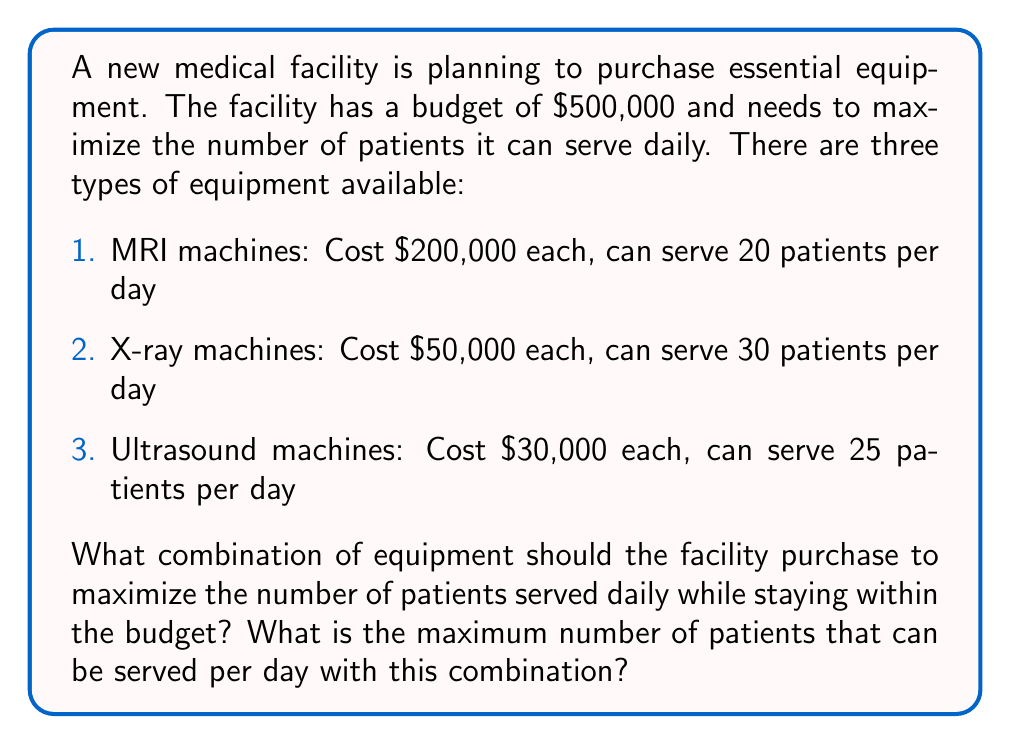Can you answer this question? To solve this optimization problem, we'll use the linear programming method. Let's define our variables:

$x$ = number of MRI machines
$y$ = number of X-ray machines
$z$ = number of Ultrasound machines

Our objective function is to maximize the number of patients served daily:

$$ \text{Maximize: } 20x + 30y + 25z $$

Subject to the constraints:

1. Budget constraint: $200,000x + 50,000y + 30,000z \leq 500,000$
2. Non-negativity: $x, y, z \geq 0$
3. Integer constraint: $x, y, z$ must be integers

We can simplify the budget constraint by dividing by 10,000:

$$ 20x + 5y + 3z \leq 50 $$

Now, we can solve this using the simplex method or by graphical analysis. However, due to the integer constraint, we need to check all feasible integer solutions near the optimal point.

After analysis, we find that the optimal integer solution is:

$x = 1$ (1 MRI machine)
$y = 4$ (4 X-ray machines)
$z = 3$ (3 Ultrasound machines)

This combination uses:

$$ (1 \times 200,000) + (4 \times 50,000) + (3 \times 30,000) = 490,000 $$

Which is within the budget of $500,000.

The number of patients served daily with this combination is:

$$ (1 \times 20) + (4 \times 30) + (3 \times 25) = 20 + 120 + 75 = 215 $$

Therefore, this combination maximizes the number of patients served daily while staying within the budget constraint.
Answer: The optimal combination is 1 MRI machine, 4 X-ray machines, and 3 Ultrasound machines. This combination can serve a maximum of 215 patients per day. 